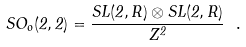Convert formula to latex. <formula><loc_0><loc_0><loc_500><loc_500>S O _ { o } ( 2 , 2 ) = \frac { S L ( 2 , { R } ) \otimes S L ( 2 , { R } ) } { Z ^ { 2 } } \ .</formula> 